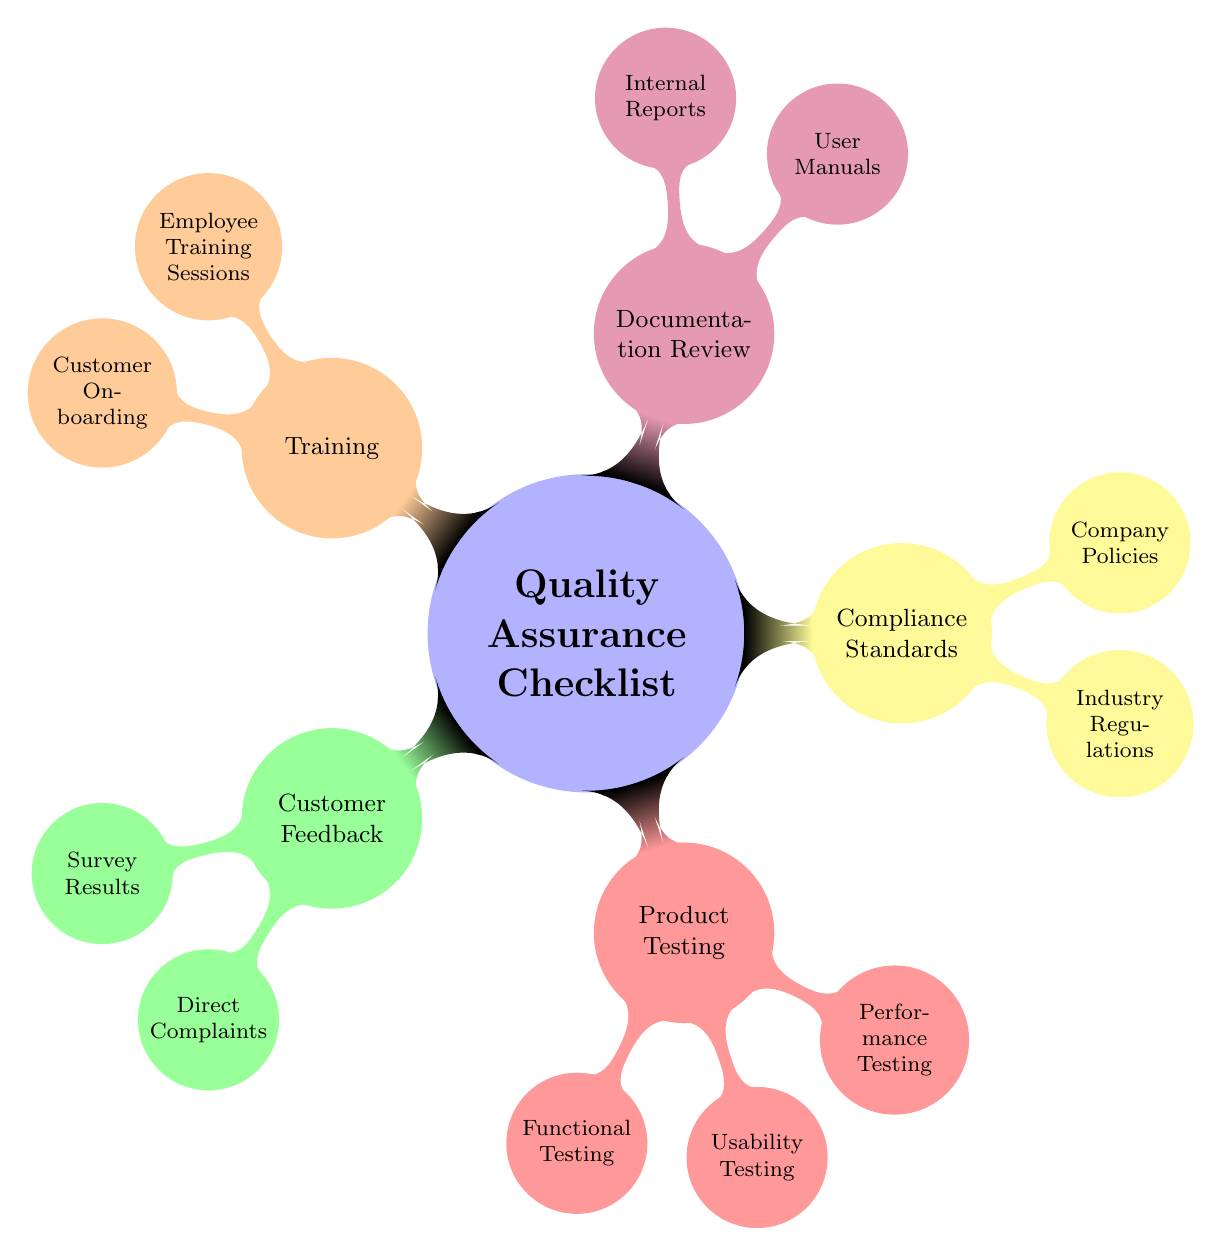What is the primary focus of the mind map? The primary focus of the mind map is indicated by the central node labeled "Quality Assurance Checklist," which is the main topic that branches out into several subcategories.
Answer: Quality Assurance Checklist How many main categories are there under the Quality Assurance Checklist? The diagram displays five main categories branching from the central topic: Customer Feedback, Product Testing, Compliance Standards, Documentation Review, and Training.
Answer: Five Which category contains Functional Testing? Functional Testing is one of the subcategories under the category labeled "Product Testing."
Answer: Product Testing What are the two subcategories under Customer Feedback? The two subcategories listed under Customer Feedback are Survey Results and Direct Complaints, which branch directly from the Customer Feedback node.
Answer: Survey Results and Direct Complaints Which category has the least number of subcategories? The "Customer Feedback" category and the "Compliance Standards" category both have only two subcategories each, making them the categories with the least number of subcategories.
Answer: Customer Feedback and Compliance Standards What is the relationship between User Manuals and the mind map's primary focus? User Manuals are a part of the Documentation Review category, which is one of the five main branches supporting the primary focus of the checklist.
Answer: Documentation Review How many types of testing are mentioned under Product Testing? The diagram lists three types of testing under Product Testing: Functional Testing, Usability Testing, and Performance Testing, indicating a focus on different aspects of product quality evaluation.
Answer: Three Which category would you refer to for ensuring compliance with industry regulations? You would refer to the Compliance Standards category, which includes the subcategory for Industry Regulations, showing its relevance to compliance issues.
Answer: Compliance Standards What type of training is provided under the Training category? The Training category includes two subcategories, Employee Training Sessions and Customer Onboarding, indicating the types of training provided.
Answer: Employee Training Sessions and Customer Onboarding 